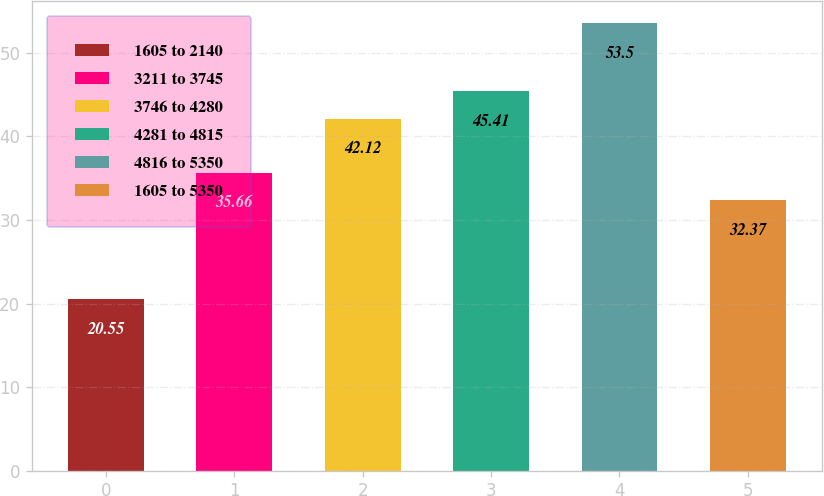Convert chart. <chart><loc_0><loc_0><loc_500><loc_500><bar_chart><fcel>1605 to 2140<fcel>3211 to 3745<fcel>3746 to 4280<fcel>4281 to 4815<fcel>4816 to 5350<fcel>1605 to 5350<nl><fcel>20.55<fcel>35.66<fcel>42.12<fcel>45.41<fcel>53.5<fcel>32.37<nl></chart> 